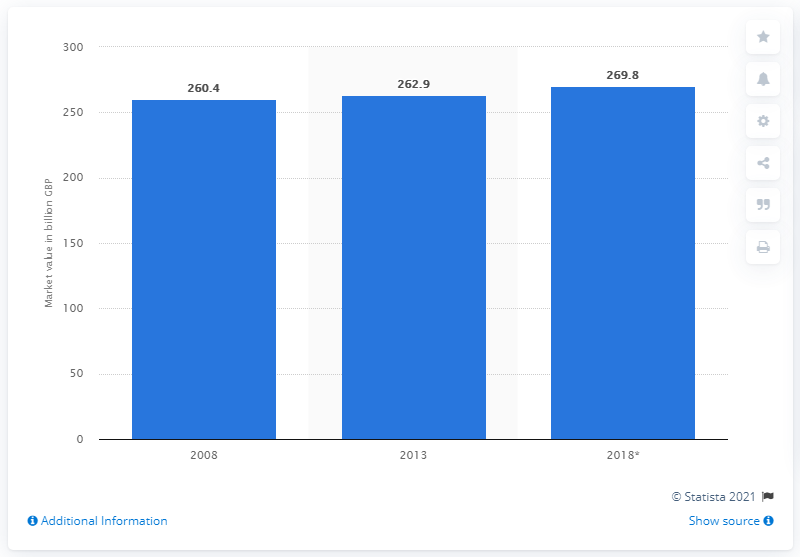Give some essential details in this illustration. According to the data provided, the expected value of the luxury retail sector in 2018 was 269.8. In 2013, the luxury retail sector was valued at 262.9 billion U.S. dollars. 